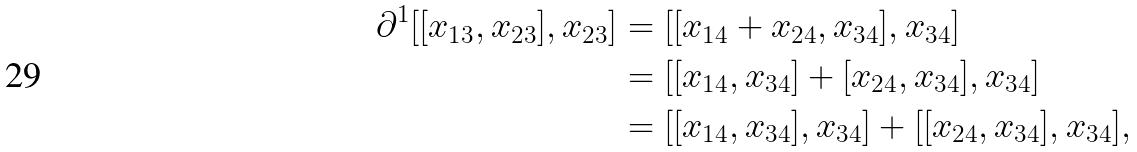Convert formula to latex. <formula><loc_0><loc_0><loc_500><loc_500>\partial ^ { 1 } [ [ x _ { 1 3 } , x _ { 2 3 } ] , x _ { 2 3 } ] & = [ [ x _ { 1 4 } + x _ { 2 4 } , x _ { 3 4 } ] , x _ { 3 4 } ] \\ & = [ [ x _ { 1 4 } , x _ { 3 4 } ] + [ x _ { 2 4 } , x _ { 3 4 } ] , x _ { 3 4 } ] \\ & = [ [ x _ { 1 4 } , x _ { 3 4 } ] , x _ { 3 4 } ] + [ [ x _ { 2 4 } , x _ { 3 4 } ] , x _ { 3 4 } ] , \\</formula> 